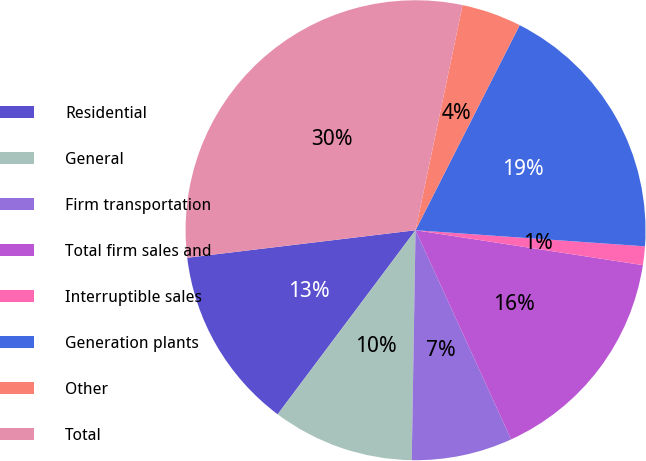<chart> <loc_0><loc_0><loc_500><loc_500><pie_chart><fcel>Residential<fcel>General<fcel>Firm transportation<fcel>Total firm sales and<fcel>Interruptible sales<fcel>Generation plants<fcel>Other<fcel>Total<nl><fcel>12.86%<fcel>9.97%<fcel>7.09%<fcel>15.75%<fcel>1.31%<fcel>18.64%<fcel>4.2%<fcel>30.19%<nl></chart> 